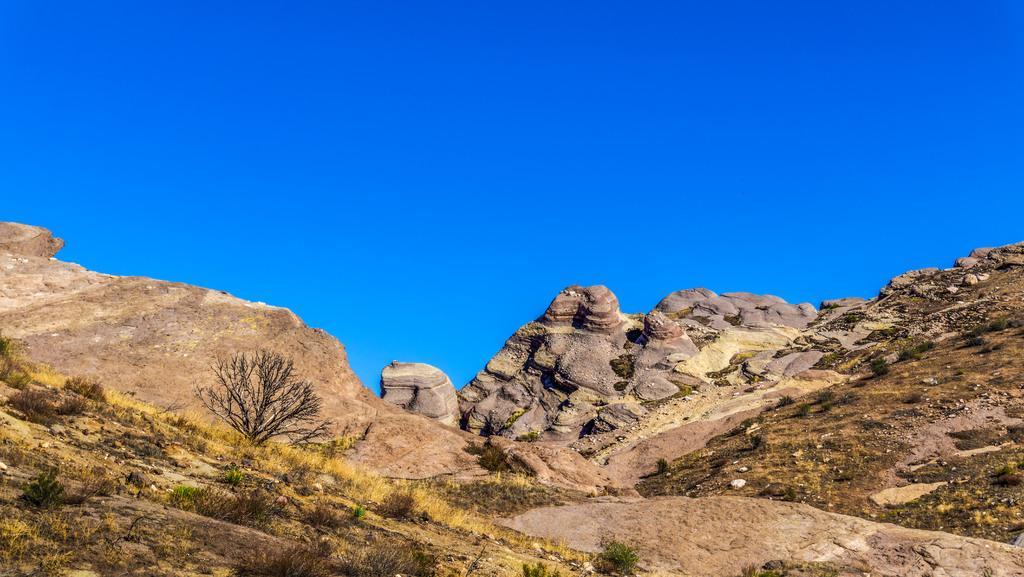In one or two sentences, can you explain what this image depicts? In this image I can see mountains, rocks and trees at the bottom of the image. At the top of the image I can see the sky. 